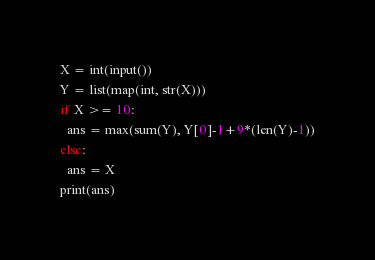<code> <loc_0><loc_0><loc_500><loc_500><_Python_>X = int(input())
Y = list(map(int, str(X)))
if X >= 10:
  ans = max(sum(Y), Y[0]-1+9*(len(Y)-1))
else:
  ans = X
print(ans)
</code> 